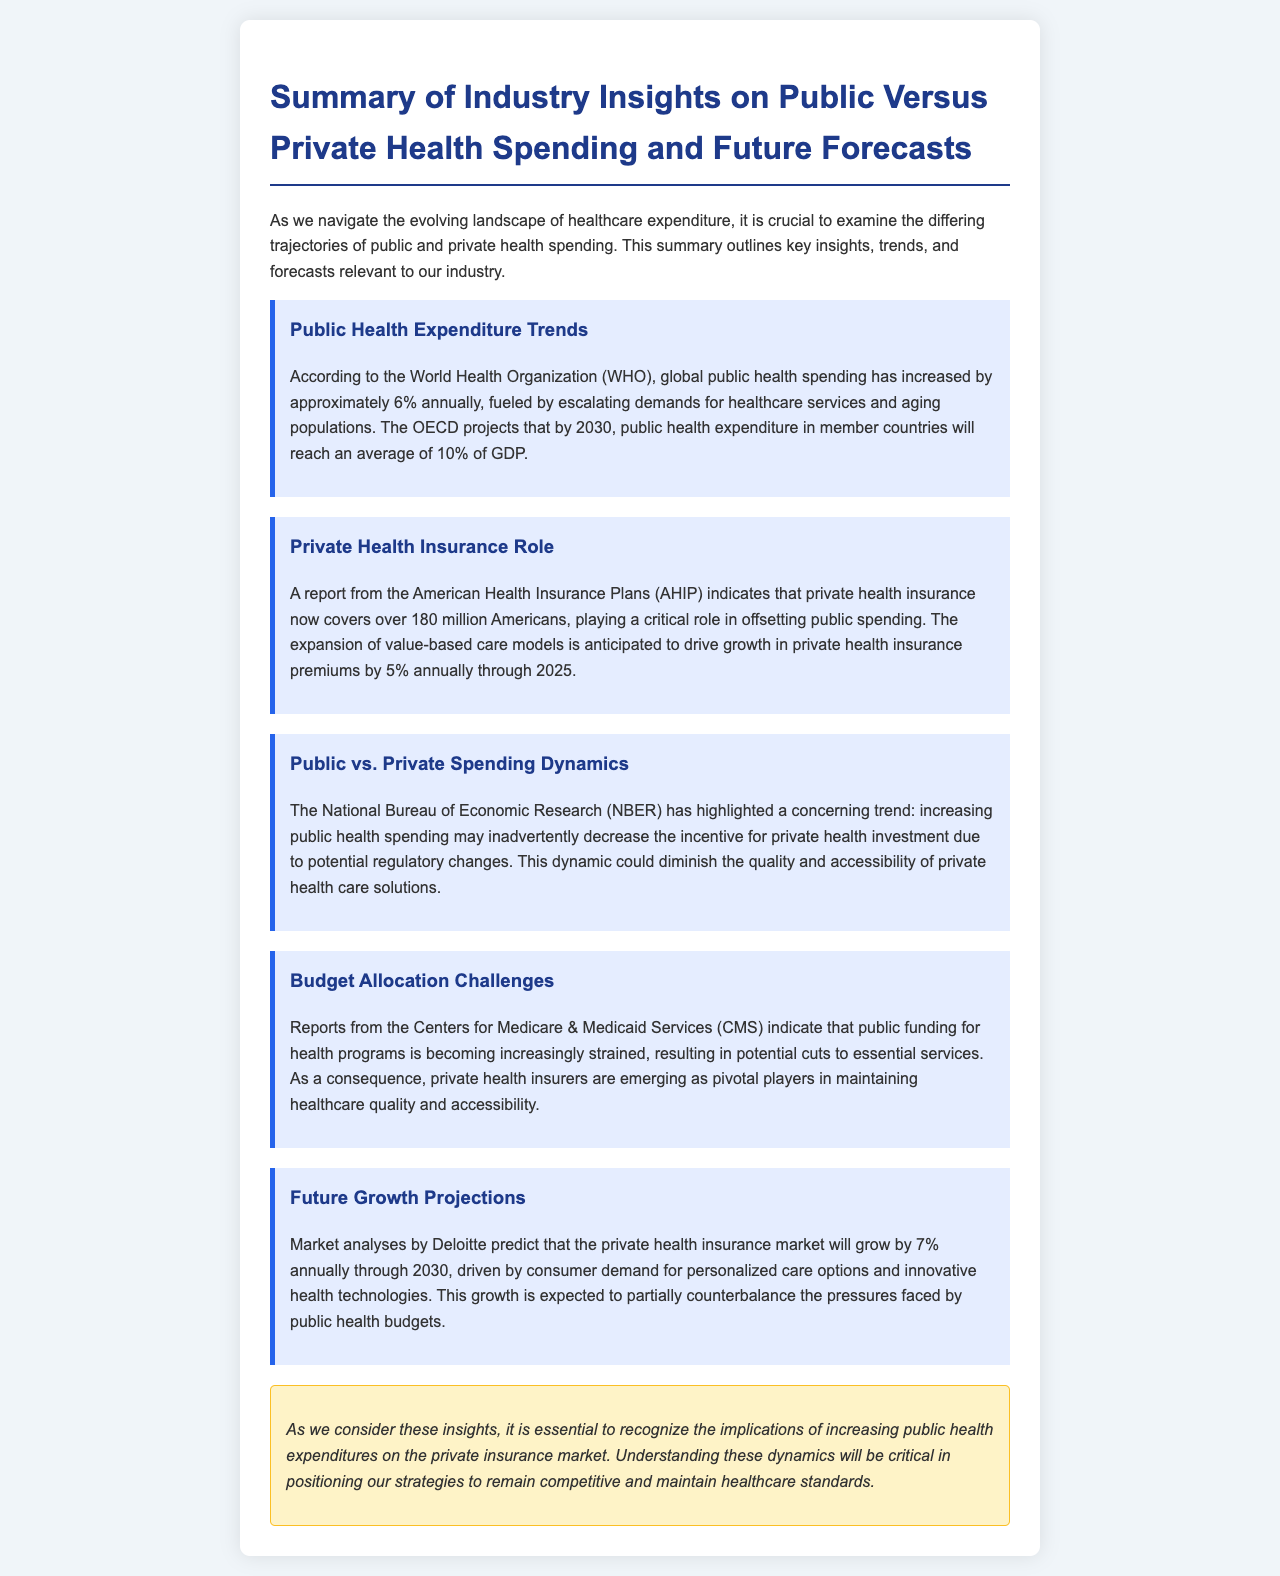What is the annual increase in global public health spending? The document states that global public health spending has increased by approximately 6% annually.
Answer: 6% How many Americans are covered by private health insurance? According to the document, private health insurance now covers over 180 million Americans.
Answer: 180 million What is the projected average percentage of GDP for public health expenditure by 2030? The OECD projects that public health expenditure in member countries will reach an average of 10% of GDP by 2030.
Answer: 10% What may decrease due to increasing public health spending? The document highlights that increasing public health spending may inadvertently decrease the incentive for private health investment.
Answer: Private health investment What is the anticipated annual growth rate for private health insurance premiums through 2025? A report indicates that the expansion of value-based care models will drive growth in private health insurance premiums by 5% annually through 2025.
Answer: 5% What is the forecasted annual growth rate for the private health insurance market through 2030? Market analyses predict that the private health insurance market will grow by 7% annually through 2030.
Answer: 7% What organization projects potential cuts to essential services due to strained public funding? Reports from the Centers for Medicare & Medicaid Services (CMS) indicate that public funding for health programs is becoming increasingly strained.
Answer: CMS What type of care options are driving consumer demand in private health insurance? Consumer demand is driven by personalized care options and innovative health technologies.
Answer: Personalized care options and innovative health technologies What is the conclusion's emphasis regarding public health expenditures? The conclusion emphasizes the implications of increasing public health expenditures on the private insurance market.
Answer: Implications of increasing public health expenditures 